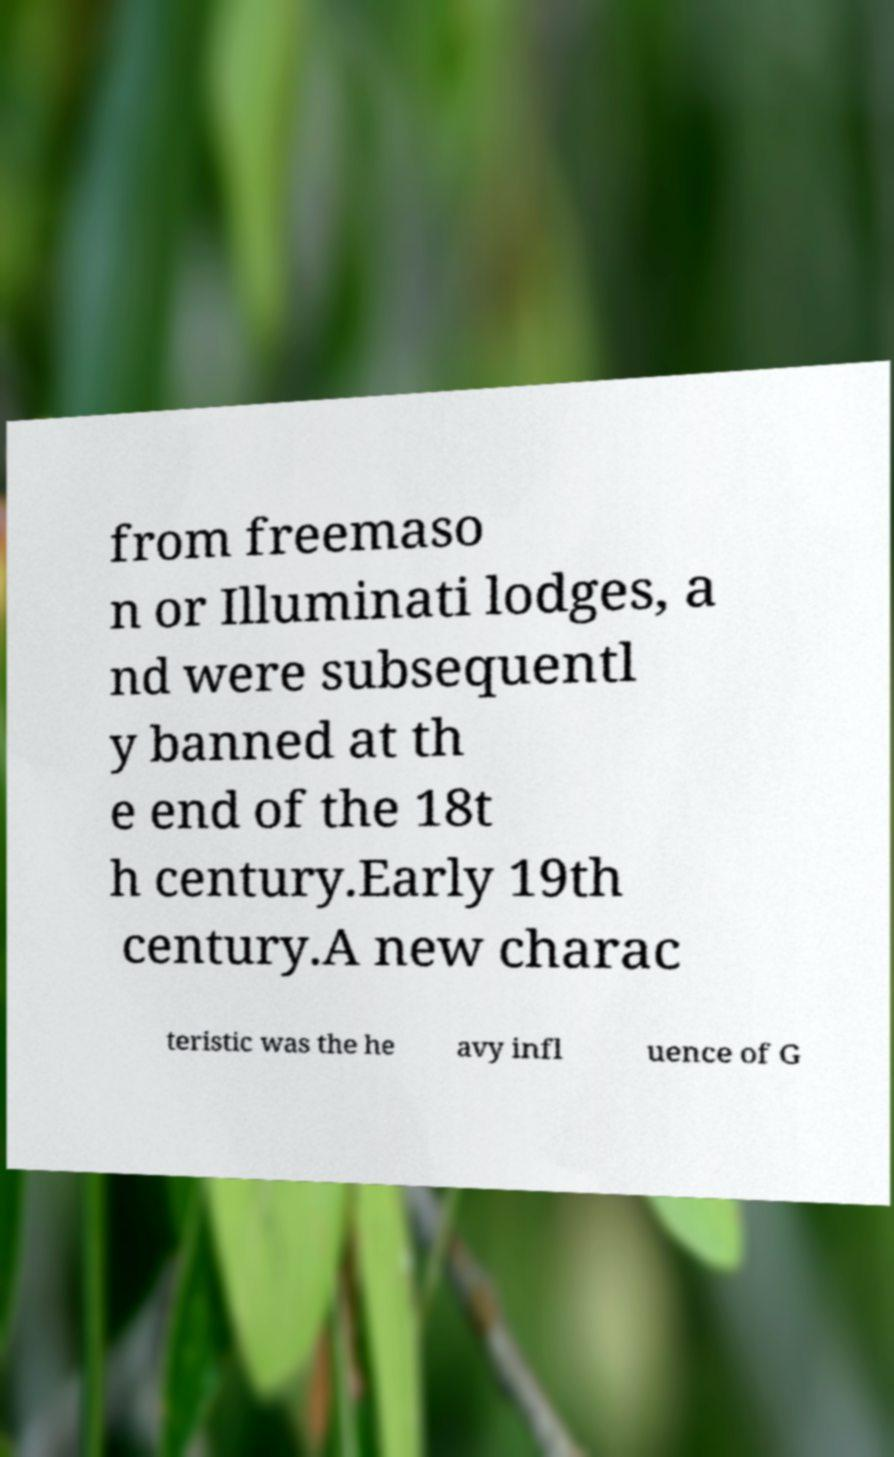I need the written content from this picture converted into text. Can you do that? from freemaso n or Illuminati lodges, a nd were subsequentl y banned at th e end of the 18t h century.Early 19th century.A new charac teristic was the he avy infl uence of G 